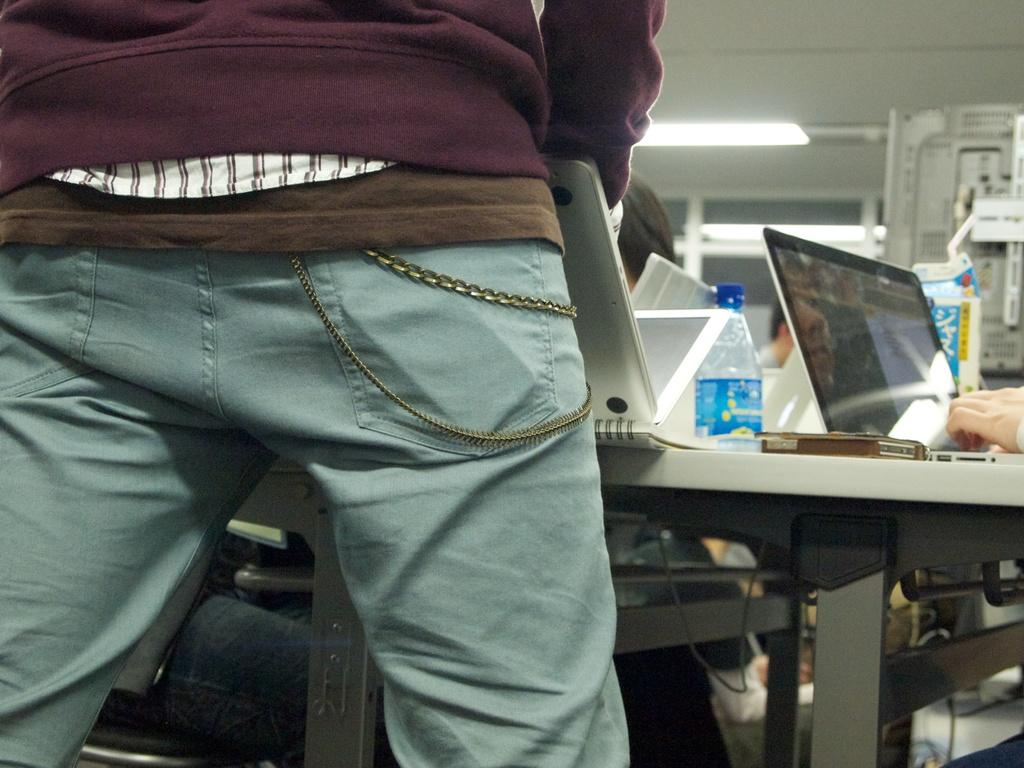How many people are in the image? There is a group of people in the image. What is the man in front of the table doing? The man is standing in front of a table and holding a laptop. What items can be seen on the table? There are bottles, laptops, and mobiles on the table. What type of tongue can be seen sticking out of the crowd in the image? There is no tongue sticking out of the crowd in the image. What point is the man trying to make by holding the laptop in the image? The image does not provide any information about the man's intentions or the point he is trying to make. 